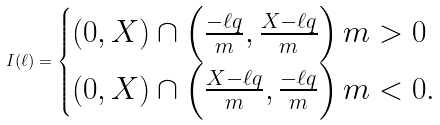<formula> <loc_0><loc_0><loc_500><loc_500>I ( \ell ) = \begin{cases} ( 0 , X ) \cap \left ( \frac { - \ell q } { m } , \frac { X - \ell q } { m } \right ) m > 0 \\ ( 0 , X ) \cap \left ( \frac { X - \ell q } { m } , \frac { - \ell q } { m } \right ) m < 0 . \end{cases}</formula> 